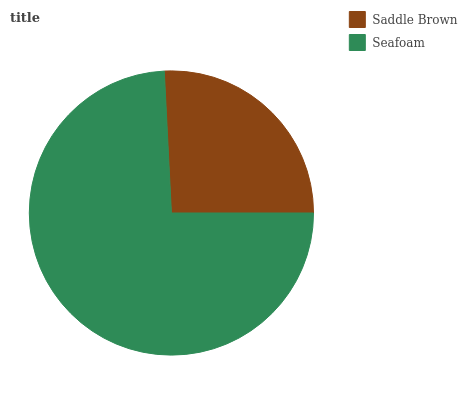Is Saddle Brown the minimum?
Answer yes or no. Yes. Is Seafoam the maximum?
Answer yes or no. Yes. Is Seafoam the minimum?
Answer yes or no. No. Is Seafoam greater than Saddle Brown?
Answer yes or no. Yes. Is Saddle Brown less than Seafoam?
Answer yes or no. Yes. Is Saddle Brown greater than Seafoam?
Answer yes or no. No. Is Seafoam less than Saddle Brown?
Answer yes or no. No. Is Seafoam the high median?
Answer yes or no. Yes. Is Saddle Brown the low median?
Answer yes or no. Yes. Is Saddle Brown the high median?
Answer yes or no. No. Is Seafoam the low median?
Answer yes or no. No. 